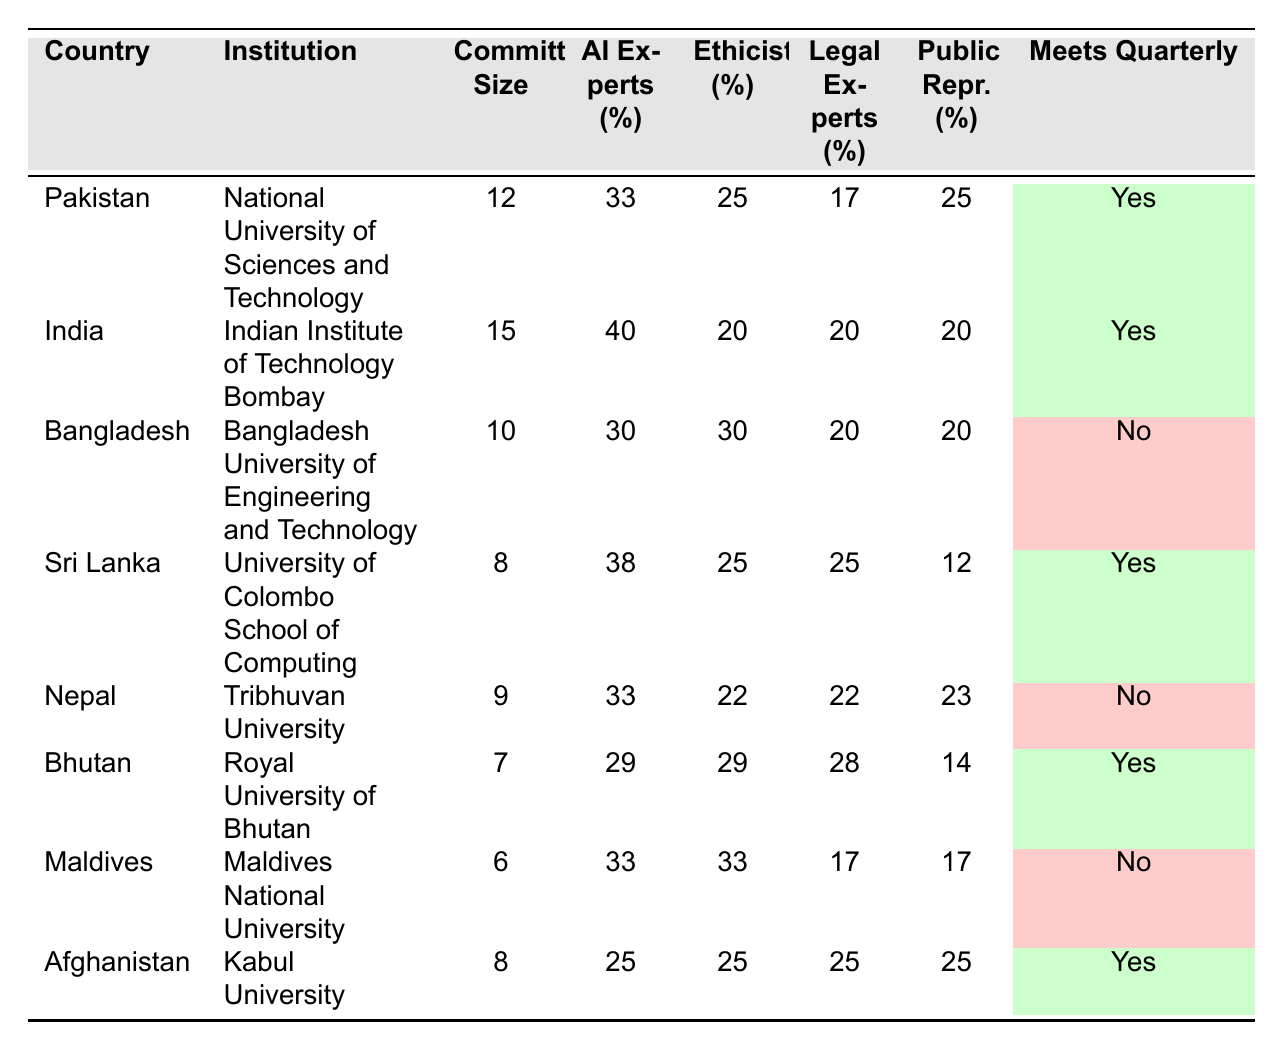What is the committee size of the Indian Institute of Technology Bombay? The table lists the committee size for each institution under the "Committee Size" column. For the Indian Institute of Technology Bombay, the size is 15.
Answer: 15 Which country has the largest committee size? By comparing the values under the "Committee Size" column, India has the largest committee size at 15.
Answer: India What percentage of legal experts is in the committee for the Royal University of Bhutan? The table displays the percentage of legal experts for each institution. For the Royal University of Bhutan, this percentage is 28%.
Answer: 28% Which country has the highest percentage of AI experts? Looking at the "AI Experts (%)" column, India has the highest percentage of AI experts at 40%.
Answer: India How many committees meet quarterly? The table indicates whether each committee meets quarterly in the "Meets Quarterly" column, with 5 entries marked as "Yes".
Answer: 5 What is the total percentage of public representatives across all committees? To find the total percentage, we need to sum the percentages from the "Public Representatives (%)" column: 25 + 20 + 20 + 12 + 23 + 14 + 17 + 25 = 166%. There are 8 countries, so the average is 166/8 = 20.75%.
Answer: 20.75% Does Bangladesh's ethics committee meet quarterly? By checking the "Meets Quarterly" column for Bangladesh, the entry shows "No", indicating that the committee does not meet quarterly.
Answer: No What percentage of AI experts is in the committee of Kabul University? The table shows that for Kabul University, the percentage of AI experts is 25%.
Answer: 25% Which institution has the lowest committee size, and what is the size? Comparing the "Committee Size" column reveals that the Maldives National University has the lowest committee size of 6.
Answer: Maldives National University, 6 How does the percentage of ethicists in Sri Lanka compare to that in Pakistan? The table shows that Sri Lanka has 25% ethicists and Pakistan has 25% as well; therefore, the percentages are the same.
Answer: Same (25%) Which country has a higher proportion of public representatives, Pakistan or Afghanistan? In Pakistan, the percentage of public representatives is 25%, while in Afghanistan it is 25% as well; therefore, there is no difference.
Answer: Same (25%) 